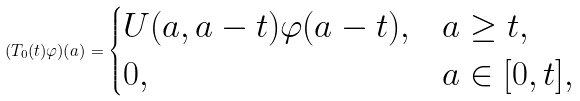<formula> <loc_0><loc_0><loc_500><loc_500>( T _ { 0 } ( t ) \varphi ) ( a ) = \begin{cases} U ( a , a - t ) \varphi ( a - t ) , & a \geq t , \\ 0 , & a \in [ 0 , t ] , \end{cases}</formula> 